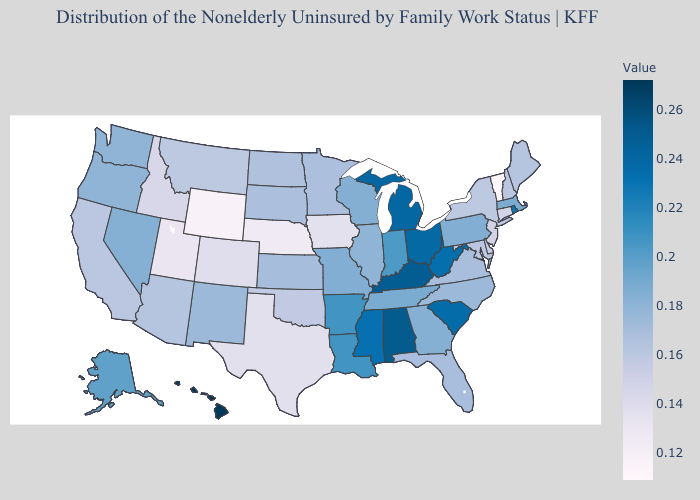Does Massachusetts have a higher value than Louisiana?
Keep it brief. No. Among the states that border Texas , does Oklahoma have the lowest value?
Short answer required. Yes. Among the states that border Minnesota , does Wisconsin have the lowest value?
Write a very short answer. No. Among the states that border Michigan , does Wisconsin have the lowest value?
Short answer required. Yes. Which states have the highest value in the USA?
Keep it brief. Hawaii. Among the states that border Rhode Island , does Massachusetts have the lowest value?
Be succinct. No. Does Iowa have the lowest value in the USA?
Short answer required. No. Does Alabama have the highest value in the South?
Concise answer only. Yes. Does Rhode Island have the highest value in the Northeast?
Give a very brief answer. Yes. 